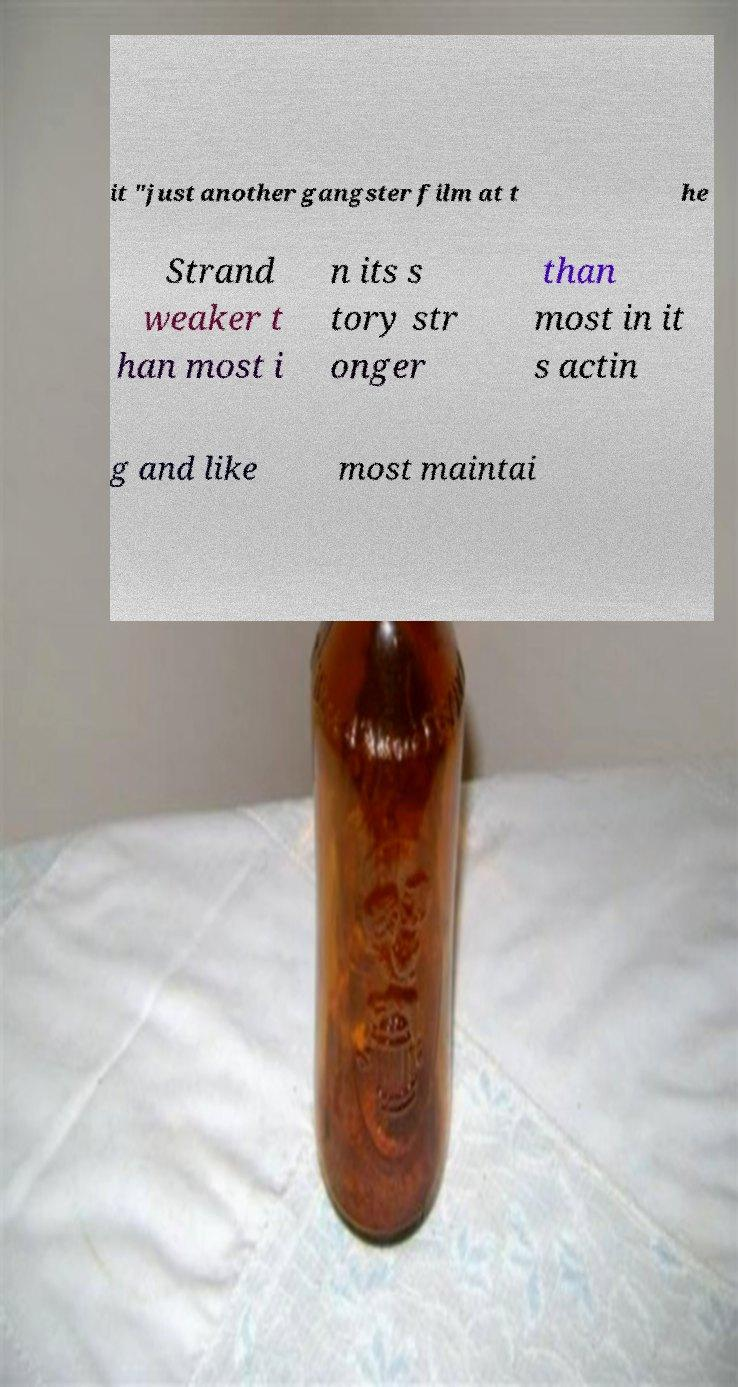For documentation purposes, I need the text within this image transcribed. Could you provide that? it "just another gangster film at t he Strand weaker t han most i n its s tory str onger than most in it s actin g and like most maintai 